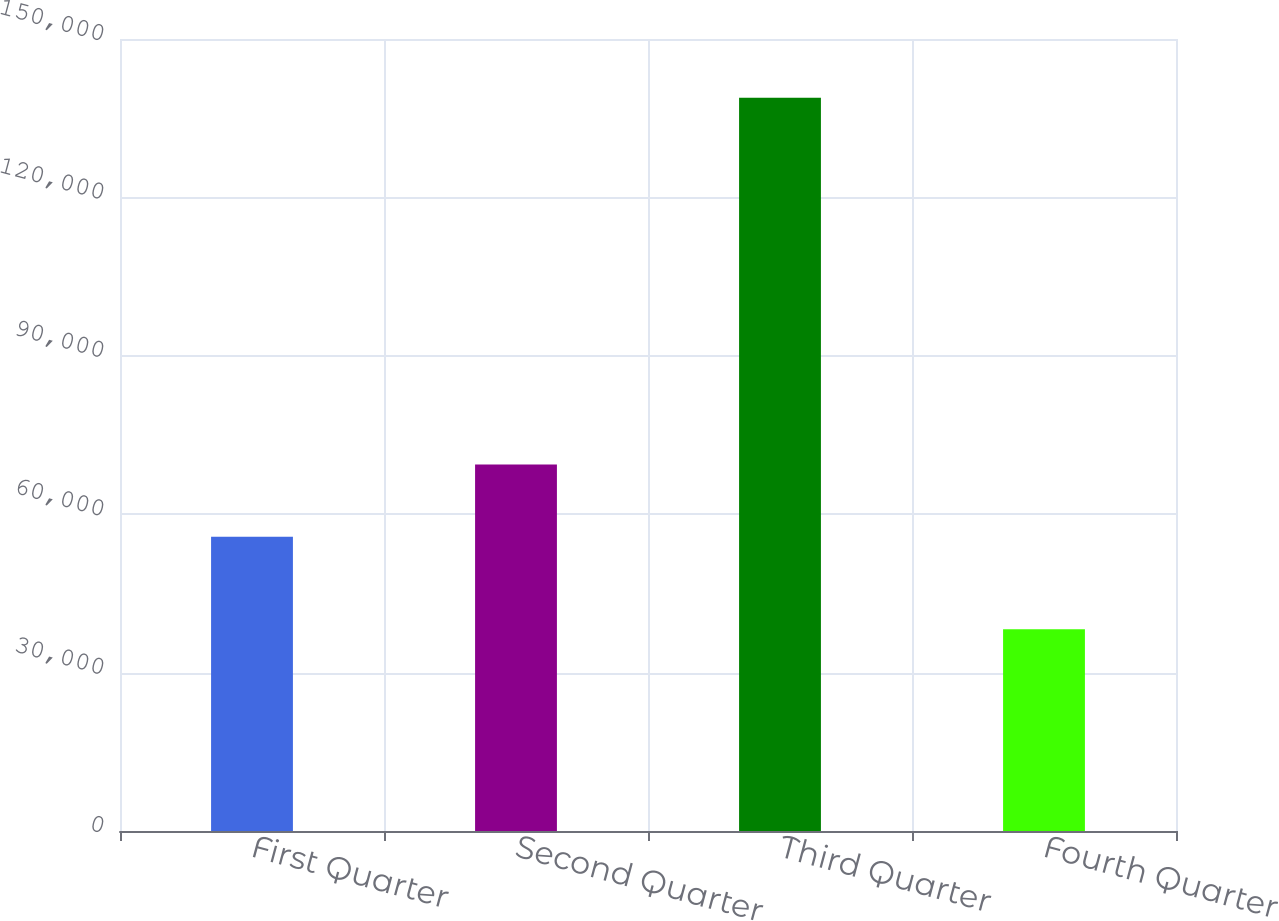<chart> <loc_0><loc_0><loc_500><loc_500><bar_chart><fcel>First Quarter<fcel>Second Quarter<fcel>Third Quarter<fcel>Fourth Quarter<nl><fcel>55731<fcel>69394<fcel>138887<fcel>38197<nl></chart> 